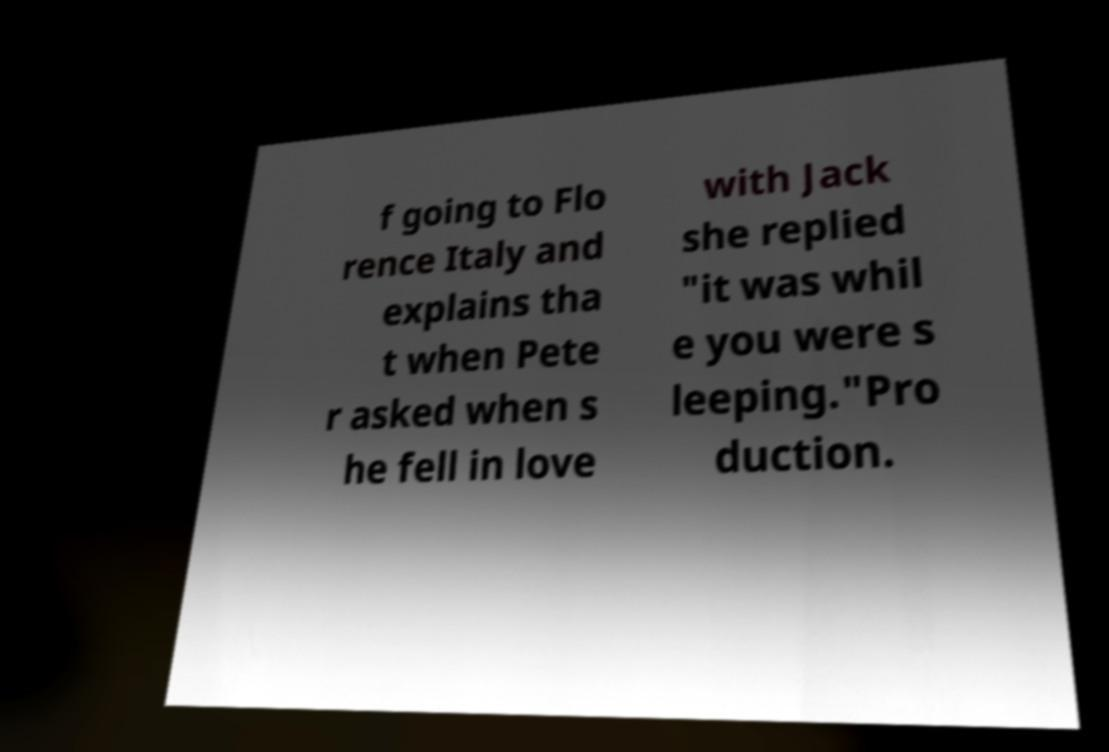Can you read and provide the text displayed in the image?This photo seems to have some interesting text. Can you extract and type it out for me? f going to Flo rence Italy and explains tha t when Pete r asked when s he fell in love with Jack she replied "it was whil e you were s leeping."Pro duction. 